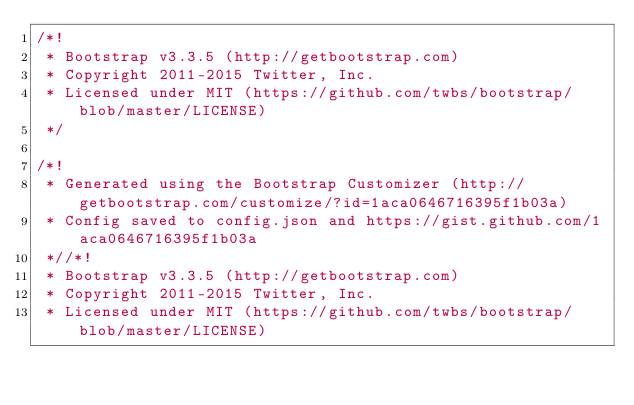Convert code to text. <code><loc_0><loc_0><loc_500><loc_500><_CSS_>/*!
 * Bootstrap v3.3.5 (http://getbootstrap.com)
 * Copyright 2011-2015 Twitter, Inc.
 * Licensed under MIT (https://github.com/twbs/bootstrap/blob/master/LICENSE)
 */

/*!
 * Generated using the Bootstrap Customizer (http://getbootstrap.com/customize/?id=1aca0646716395f1b03a)
 * Config saved to config.json and https://gist.github.com/1aca0646716395f1b03a
 *//*!
 * Bootstrap v3.3.5 (http://getbootstrap.com)
 * Copyright 2011-2015 Twitter, Inc.
 * Licensed under MIT (https://github.com/twbs/bootstrap/blob/master/LICENSE)</code> 